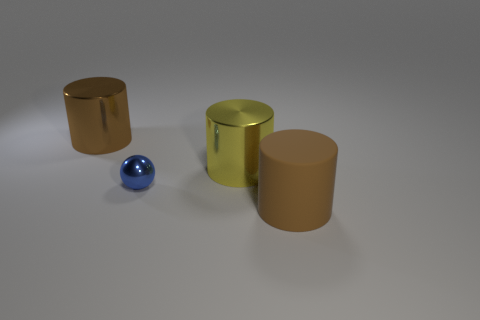If these objects were part of a larger set, what function might they serve together? Given their different shapes and materials, they might be part of a decorative set intended for an artistic display. Alternatively, if they were functional, they might represent containers or stands for different sized objects in a matching set. 